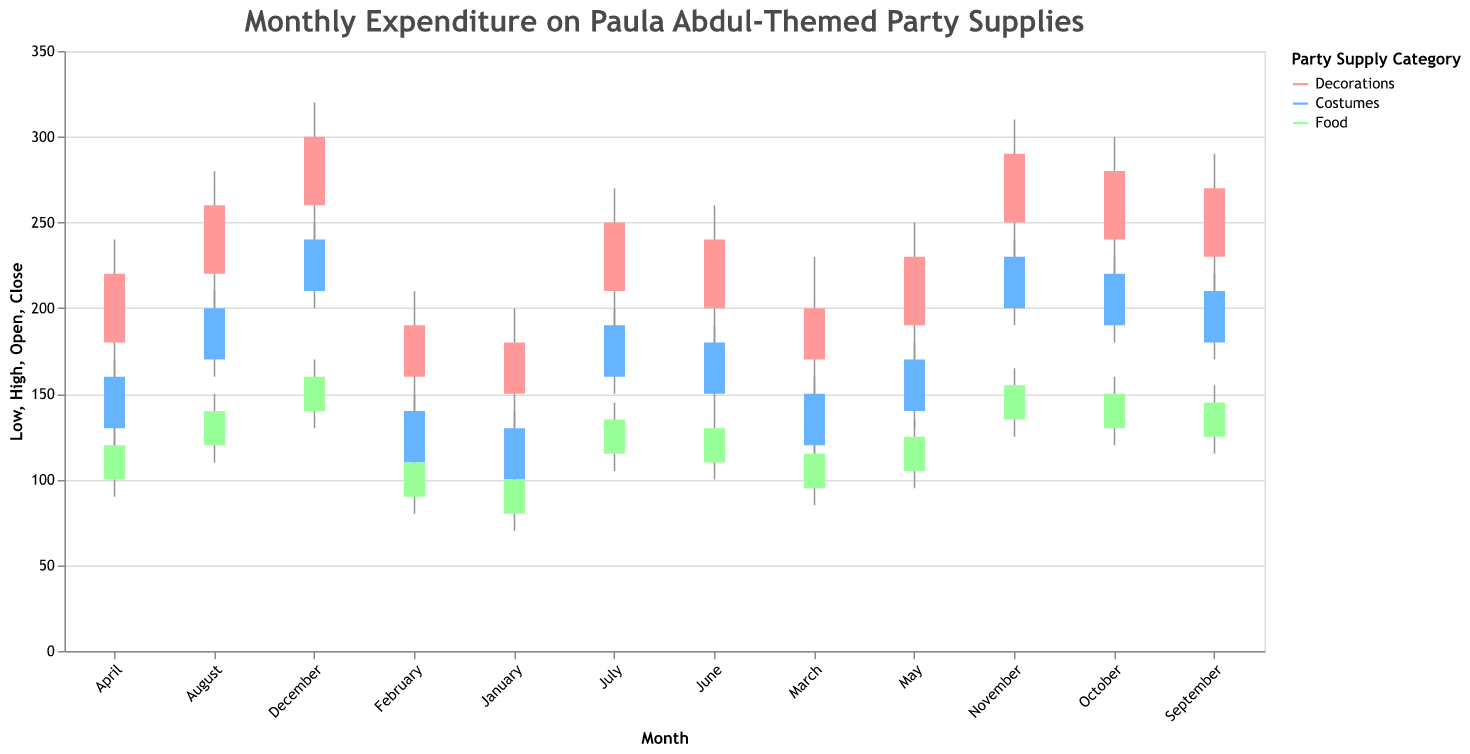What is the title of the plot? The title is found at the top of the plot. It provides a summary of the data being shown.
Answer: Monthly Expenditure on Paula Abdul-Themed Party Supplies How many categories are displayed in the figure, and what are their corresponding colors? The number of categories and their colors are determined by the different hues used in the plot and their associated legend labels.
Answer: Three categories: Decorations (light red), Costumes (light blue), Food (light green) Which month has the highest recorded expenditure for decorations? Find the month with the highest 'High' value for the Decorations category.
Answer: December What's the difference between the highest and lowest expenditure for costumes in March? The difference is calculated by subtracting the 'Low' value from the 'High' value for Costumes in March.
Answer: 50 (160 - 110 = 50) In which month did food expenditures start at $100? Look at the 'Open' value for the Food category in each month to find where it equals $100.
Answer: June What's the average starting expenditure for decorations from January to April? Sum the 'Open' value for Decorations from January to April, then divide by the number of months (4).
Answer: 165 ((150+160+170+180)/4 = 165) How many months show a closing expenditure of $190 for costumes? Count the number of months where the 'Close' value for Costumes is $190.
Answer: Two months (July, September) Which category has the smallest range (High - Low) in August? Calculate the range for each category in August and find the smallest.
Answer: Food (40, calculated as 150-110) In which month did the food category have its highest ending expenditure, and what was the value? Find the month with the highest 'Close' value for the Food category and the corresponding value.
Answer: December, $160 Between November and December, which month saw a greater increase in closing expenditure for decorations? Compare the 'Close' values for Decorations in November and December to find the larger increase.
Answer: December 